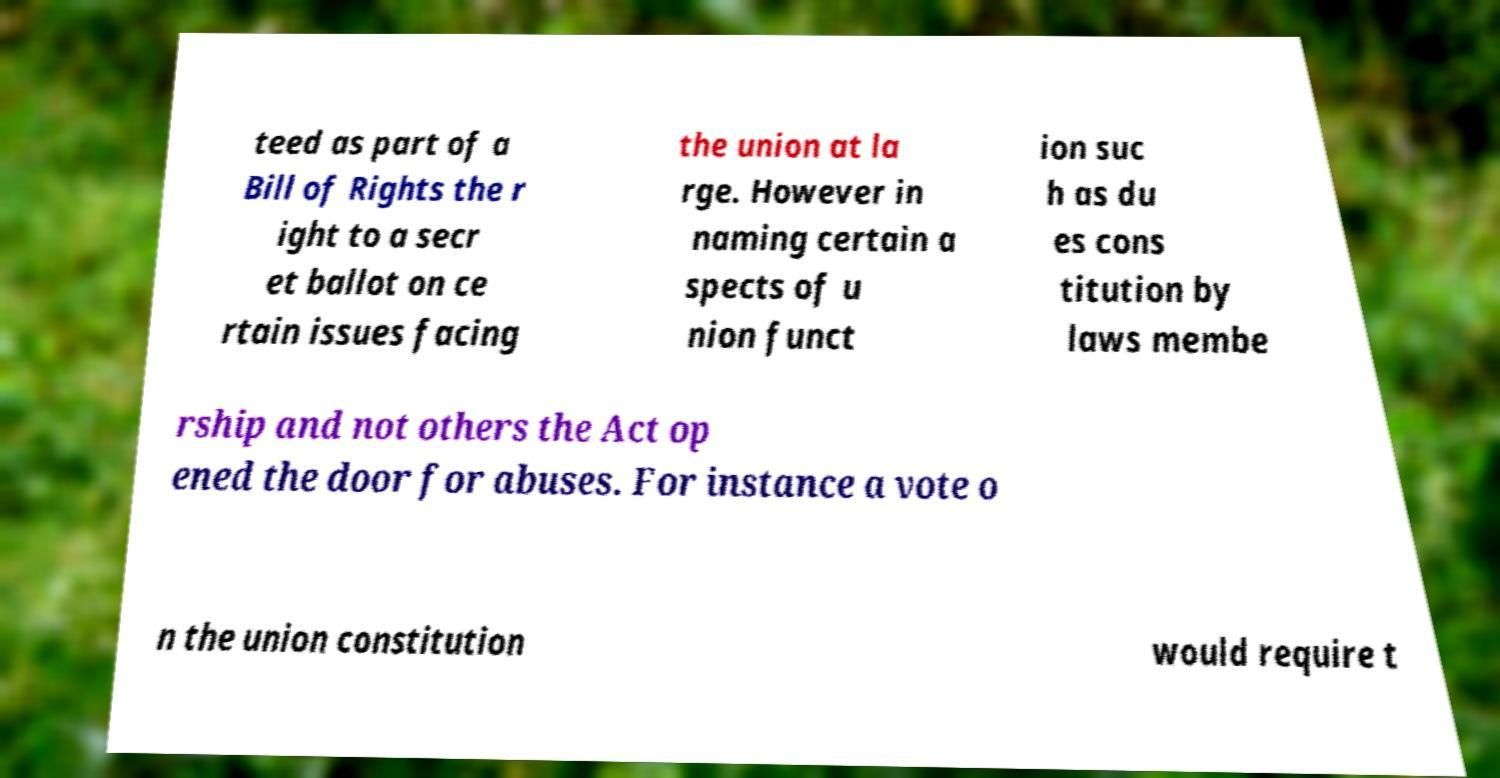Could you assist in decoding the text presented in this image and type it out clearly? teed as part of a Bill of Rights the r ight to a secr et ballot on ce rtain issues facing the union at la rge. However in naming certain a spects of u nion funct ion suc h as du es cons titution by laws membe rship and not others the Act op ened the door for abuses. For instance a vote o n the union constitution would require t 